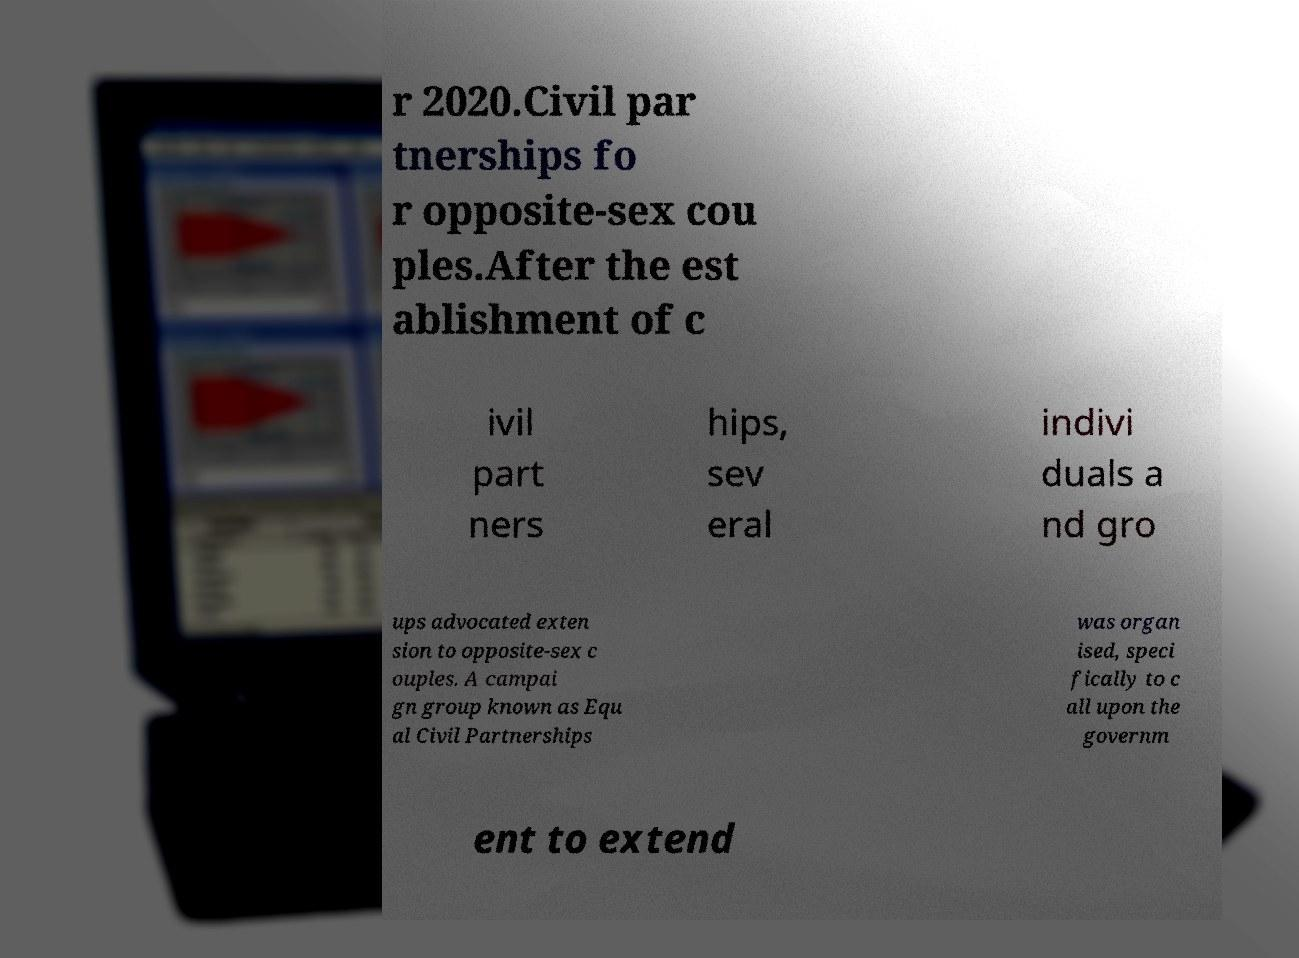What messages or text are displayed in this image? I need them in a readable, typed format. r 2020.Civil par tnerships fo r opposite-sex cou ples.After the est ablishment of c ivil part ners hips, sev eral indivi duals a nd gro ups advocated exten sion to opposite-sex c ouples. A campai gn group known as Equ al Civil Partnerships was organ ised, speci fically to c all upon the governm ent to extend 